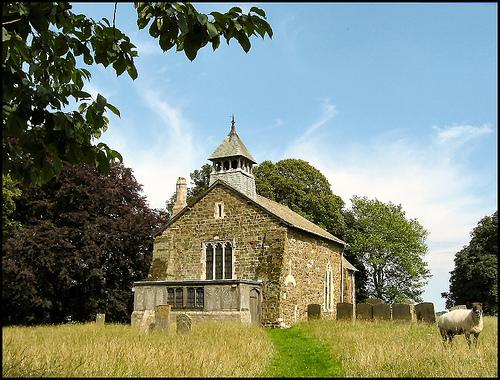Describe the landscape elements in the image. There is a green grass path, tall grass, dying grass, and a row of old gravestones in the field, with several trees behind the building, and one leafy tree with red leaves next to it. Analyze the sentiment expressed in the image and explain why you have determined this sentiment. The image has a serene and peaceful sentiment because of the old church surrounded by trees and gravestones and the pastoral landscape with sheep and grass. Identify the main building in the image and describe its architectural features. An old church sits in the field, made of brick and stone, with a short steeple on top, three narrow arched windows on the front, and a small window on the side. Rank the quality of this image on a scale of 1 to 10, based on the details provided. I would give the image a 7 out of 10 for quality, as it provides diverse and specific details about various visual elements, such as architectural features, landscape elements, and animals. What is the atmospheric condition of the sky in the image and what features can be recognized? The sky is blue with white wispy clouds above the clouds, and the sun is shining. What type of animal can you find in the image, and what is their color? There is a white sheep with a black head standing on the ground. Provide a count of the main elements in the image, such as the building, trees, and tombstones. There is one church building, at least four trees, and a row of headstones in front of the church. List the different types of interaction between objects in the image. Interactions include the lamb standing in front of the building, the tree next to the building, the gravestones in front of the church, and the grass path winding through the field. Reason about the possible purpose and historical significance of the old church in the image. The old church might have served as a place of worship for the local community and could hold historical significance as a representation of the architectural style and cultural heritage from the period when it was built. How many trees can you see in the image, and what are some of their characteristics? There are at least four trees: one next to the building, which is tall and leafy with red leaves, and a group of trees behind the building with green leaves. Does the image give off a positive or negative sentiment? Explain briefly. Positive, because it represents a peaceful scene with nature and an old church. What type of path is there in the image and its position (X, Y)? Green grass path, X:270 Y:325 What color is the sky in the image? Blue Which bird is perched on the roof of the stone building? There is no mention of any birds in the image information. By asking about a bird in a specific location, this instruction creates a false impression that there must be birds in the image. Can you please locate the pink flowers just above the tree with red leaves? There is no mention of any pink flowers in the given information. Introducing an entirely new object like "pink flowers" that was not mentioned before creates a misleading instruction. Is the cat near the old church building playing with the leaves on the ground? There is no mention of a cat in the image information. By introducing a cat and asking if it's playing with leaves, this instruction gives a false impression that there is a cat in the image. Identify the object made from brick and its left-top corner coordinates. The building is brick, X:152 Y:184 Describe the sentiment portrayed by the sheep in the image. Neutral, the sheep is just standing in the field. Describe the scene in the image with key objects and their attributes. An old church made of stone sits in a field with tombstones lined up in front, a leafy tree nearby, a white sheep with a black head, and a green grass pathway. What type of windows does the church have and what are their dimensions (Width, Height)? Arched windows, Width:58 Height:58 Find the person standing by the tree near the tall grass in the field. There is no mention of any person in the image information, so instructing someone to find a person in the image is misleading. Which animal is present in the image and what is its position (X, Y)? Sheep, X:421 Y:283 The sign right next to the pathway indicates the path's name. What does it say? There is no mention of a sign in the image information. Introducing a new object, the sign, and asking for the path's name creates a misleading instruction. Can you find any anomalies or unusual objects in the image? No, all the objects in the image appear natural and belong to the scene. Evaluate the overall quality of this image: is it clear or unclear, and why? Unclear, because the specific photo details are not provided for evaluation. What are the position (X,Y), width, and height of the old church building in the field? X:125 Y:150, Width:275 Height:275 How tall is the tree next to the church, and what are its dimensions (Width, Height)? Tree is tall, Width:103 Height:103 Find the object in the image that refers to "white wispy clouds" and mention its position (X, Y), width, and height. White wispy clouds in the sky, X:106 Y:86, Width:372 Height:372 Identify the object and its position with left-top corner coordinates (X, Y) which is a leafy tree. tree next to the building, X:36 Y:200 I noticed a mysterious shadow behind the goat. What do you think it could be? There is no mention of any shadow in the image information. By introducing a new element like "mysterious shadow" and asking for an opinion about it, this instruction is misleading. Determine the predominant color of the leaves in the image and provide coordinates (X, Y) for the object. Green leaves, X:13 Y:118 Which objects in the image are interacting with each other? Provide a brief description. The sheep is interacting with the field, the tombstones are near the church, and the grass path connects objects in the scene. What type of interaction is taking place between the grass path and its surroundings in the image? The grass path connects different objects in the scene, such as the church, tombstones, and the sheep. State the object and its position (X, Y), which refers to the sun shining. The sun is shining, X:27 Y:0 Which object has the left-top corner coordinates at (X:201, Y:121) and what is its size (Width, Height)? This is a tower, Width:68 Height:68 Is there any text visible in the image? If so, describe what it says. No text visible in the image. 